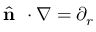<formula> <loc_0><loc_0><loc_500><loc_500>\hat { n } \cdot \nabla = \partial _ { r }</formula> 